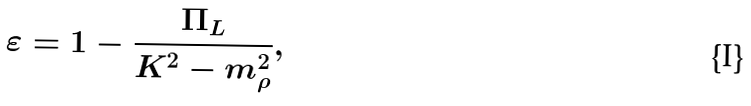Convert formula to latex. <formula><loc_0><loc_0><loc_500><loc_500>\varepsilon = 1 - \frac { \Pi _ { L } } { K ^ { 2 } - m ^ { 2 } _ { \rho } } ,</formula> 